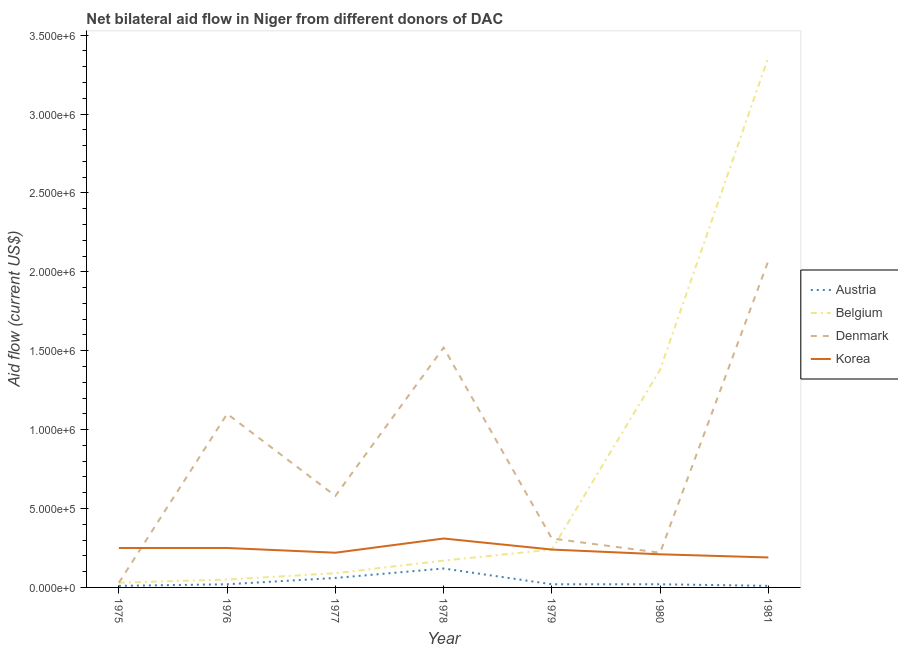How many different coloured lines are there?
Keep it short and to the point. 4. Does the line corresponding to amount of aid given by austria intersect with the line corresponding to amount of aid given by korea?
Keep it short and to the point. No. What is the amount of aid given by denmark in 1977?
Your answer should be very brief. 5.80e+05. Across all years, what is the maximum amount of aid given by korea?
Provide a succinct answer. 3.10e+05. Across all years, what is the minimum amount of aid given by belgium?
Make the answer very short. 3.00e+04. In which year was the amount of aid given by denmark minimum?
Your response must be concise. 1975. What is the total amount of aid given by belgium in the graph?
Provide a short and direct response. 5.32e+06. What is the difference between the amount of aid given by korea in 1975 and that in 1980?
Keep it short and to the point. 4.00e+04. What is the difference between the amount of aid given by denmark in 1981 and the amount of aid given by belgium in 1975?
Provide a succinct answer. 2.04e+06. What is the average amount of aid given by belgium per year?
Your answer should be compact. 7.60e+05. In the year 1981, what is the difference between the amount of aid given by korea and amount of aid given by denmark?
Provide a succinct answer. -1.88e+06. What is the ratio of the amount of aid given by belgium in 1979 to that in 1980?
Ensure brevity in your answer.  0.17. Is the amount of aid given by belgium in 1976 less than that in 1981?
Keep it short and to the point. Yes. Is the difference between the amount of aid given by denmark in 1976 and 1980 greater than the difference between the amount of aid given by korea in 1976 and 1980?
Your response must be concise. Yes. What is the difference between the highest and the lowest amount of aid given by denmark?
Provide a short and direct response. 2.04e+06. In how many years, is the amount of aid given by denmark greater than the average amount of aid given by denmark taken over all years?
Offer a very short reply. 3. Is the sum of the amount of aid given by denmark in 1978 and 1979 greater than the maximum amount of aid given by korea across all years?
Your answer should be compact. Yes. Is it the case that in every year, the sum of the amount of aid given by belgium and amount of aid given by austria is greater than the sum of amount of aid given by denmark and amount of aid given by korea?
Offer a terse response. No. Is it the case that in every year, the sum of the amount of aid given by austria and amount of aid given by belgium is greater than the amount of aid given by denmark?
Provide a short and direct response. No. Is the amount of aid given by austria strictly greater than the amount of aid given by korea over the years?
Your answer should be compact. No. Is the amount of aid given by austria strictly less than the amount of aid given by korea over the years?
Provide a succinct answer. Yes. Are the values on the major ticks of Y-axis written in scientific E-notation?
Offer a very short reply. Yes. Does the graph contain any zero values?
Your response must be concise. No. What is the title of the graph?
Your answer should be compact. Net bilateral aid flow in Niger from different donors of DAC. Does "WHO" appear as one of the legend labels in the graph?
Give a very brief answer. No. What is the Aid flow (current US$) of Austria in 1975?
Your response must be concise. 10000. What is the Aid flow (current US$) in Belgium in 1976?
Offer a terse response. 5.00e+04. What is the Aid flow (current US$) in Denmark in 1976?
Your response must be concise. 1.10e+06. What is the Aid flow (current US$) of Austria in 1977?
Keep it short and to the point. 6.00e+04. What is the Aid flow (current US$) of Denmark in 1977?
Offer a terse response. 5.80e+05. What is the Aid flow (current US$) in Korea in 1977?
Make the answer very short. 2.20e+05. What is the Aid flow (current US$) of Austria in 1978?
Your answer should be very brief. 1.20e+05. What is the Aid flow (current US$) of Denmark in 1978?
Provide a succinct answer. 1.52e+06. What is the Aid flow (current US$) of Korea in 1979?
Make the answer very short. 2.40e+05. What is the Aid flow (current US$) in Austria in 1980?
Make the answer very short. 2.00e+04. What is the Aid flow (current US$) in Belgium in 1980?
Your response must be concise. 1.38e+06. What is the Aid flow (current US$) of Denmark in 1980?
Give a very brief answer. 2.20e+05. What is the Aid flow (current US$) in Korea in 1980?
Offer a terse response. 2.10e+05. What is the Aid flow (current US$) of Austria in 1981?
Provide a succinct answer. 10000. What is the Aid flow (current US$) in Belgium in 1981?
Give a very brief answer. 3.36e+06. What is the Aid flow (current US$) of Denmark in 1981?
Provide a short and direct response. 2.07e+06. Across all years, what is the maximum Aid flow (current US$) of Belgium?
Provide a succinct answer. 3.36e+06. Across all years, what is the maximum Aid flow (current US$) in Denmark?
Your answer should be very brief. 2.07e+06. Across all years, what is the maximum Aid flow (current US$) in Korea?
Provide a succinct answer. 3.10e+05. Across all years, what is the minimum Aid flow (current US$) in Austria?
Your response must be concise. 10000. What is the total Aid flow (current US$) in Belgium in the graph?
Your answer should be compact. 5.32e+06. What is the total Aid flow (current US$) in Denmark in the graph?
Your answer should be very brief. 5.83e+06. What is the total Aid flow (current US$) in Korea in the graph?
Provide a succinct answer. 1.67e+06. What is the difference between the Aid flow (current US$) of Denmark in 1975 and that in 1976?
Provide a succinct answer. -1.07e+06. What is the difference between the Aid flow (current US$) in Austria in 1975 and that in 1977?
Ensure brevity in your answer.  -5.00e+04. What is the difference between the Aid flow (current US$) of Denmark in 1975 and that in 1977?
Make the answer very short. -5.50e+05. What is the difference between the Aid flow (current US$) in Korea in 1975 and that in 1977?
Keep it short and to the point. 3.00e+04. What is the difference between the Aid flow (current US$) of Denmark in 1975 and that in 1978?
Make the answer very short. -1.49e+06. What is the difference between the Aid flow (current US$) of Belgium in 1975 and that in 1979?
Offer a terse response. -2.10e+05. What is the difference between the Aid flow (current US$) of Denmark in 1975 and that in 1979?
Keep it short and to the point. -2.80e+05. What is the difference between the Aid flow (current US$) in Korea in 1975 and that in 1979?
Provide a succinct answer. 10000. What is the difference between the Aid flow (current US$) of Belgium in 1975 and that in 1980?
Your response must be concise. -1.35e+06. What is the difference between the Aid flow (current US$) of Korea in 1975 and that in 1980?
Your response must be concise. 4.00e+04. What is the difference between the Aid flow (current US$) in Austria in 1975 and that in 1981?
Ensure brevity in your answer.  0. What is the difference between the Aid flow (current US$) in Belgium in 1975 and that in 1981?
Give a very brief answer. -3.33e+06. What is the difference between the Aid flow (current US$) in Denmark in 1975 and that in 1981?
Give a very brief answer. -2.04e+06. What is the difference between the Aid flow (current US$) of Korea in 1975 and that in 1981?
Keep it short and to the point. 6.00e+04. What is the difference between the Aid flow (current US$) in Belgium in 1976 and that in 1977?
Ensure brevity in your answer.  -4.00e+04. What is the difference between the Aid flow (current US$) of Denmark in 1976 and that in 1977?
Your answer should be compact. 5.20e+05. What is the difference between the Aid flow (current US$) of Austria in 1976 and that in 1978?
Keep it short and to the point. -1.00e+05. What is the difference between the Aid flow (current US$) of Denmark in 1976 and that in 1978?
Keep it short and to the point. -4.20e+05. What is the difference between the Aid flow (current US$) of Korea in 1976 and that in 1978?
Keep it short and to the point. -6.00e+04. What is the difference between the Aid flow (current US$) of Belgium in 1976 and that in 1979?
Provide a short and direct response. -1.90e+05. What is the difference between the Aid flow (current US$) of Denmark in 1976 and that in 1979?
Ensure brevity in your answer.  7.90e+05. What is the difference between the Aid flow (current US$) in Austria in 1976 and that in 1980?
Make the answer very short. 0. What is the difference between the Aid flow (current US$) in Belgium in 1976 and that in 1980?
Ensure brevity in your answer.  -1.33e+06. What is the difference between the Aid flow (current US$) of Denmark in 1976 and that in 1980?
Keep it short and to the point. 8.80e+05. What is the difference between the Aid flow (current US$) in Austria in 1976 and that in 1981?
Provide a short and direct response. 10000. What is the difference between the Aid flow (current US$) of Belgium in 1976 and that in 1981?
Provide a succinct answer. -3.31e+06. What is the difference between the Aid flow (current US$) of Denmark in 1976 and that in 1981?
Offer a terse response. -9.70e+05. What is the difference between the Aid flow (current US$) in Austria in 1977 and that in 1978?
Offer a terse response. -6.00e+04. What is the difference between the Aid flow (current US$) in Denmark in 1977 and that in 1978?
Your answer should be very brief. -9.40e+05. What is the difference between the Aid flow (current US$) of Korea in 1977 and that in 1978?
Your answer should be compact. -9.00e+04. What is the difference between the Aid flow (current US$) in Austria in 1977 and that in 1979?
Your answer should be compact. 4.00e+04. What is the difference between the Aid flow (current US$) in Korea in 1977 and that in 1979?
Keep it short and to the point. -2.00e+04. What is the difference between the Aid flow (current US$) of Belgium in 1977 and that in 1980?
Offer a very short reply. -1.29e+06. What is the difference between the Aid flow (current US$) of Denmark in 1977 and that in 1980?
Offer a very short reply. 3.60e+05. What is the difference between the Aid flow (current US$) in Korea in 1977 and that in 1980?
Provide a short and direct response. 10000. What is the difference between the Aid flow (current US$) in Austria in 1977 and that in 1981?
Keep it short and to the point. 5.00e+04. What is the difference between the Aid flow (current US$) of Belgium in 1977 and that in 1981?
Your response must be concise. -3.27e+06. What is the difference between the Aid flow (current US$) in Denmark in 1977 and that in 1981?
Provide a succinct answer. -1.49e+06. What is the difference between the Aid flow (current US$) in Korea in 1977 and that in 1981?
Offer a terse response. 3.00e+04. What is the difference between the Aid flow (current US$) of Austria in 1978 and that in 1979?
Offer a very short reply. 1.00e+05. What is the difference between the Aid flow (current US$) of Denmark in 1978 and that in 1979?
Offer a very short reply. 1.21e+06. What is the difference between the Aid flow (current US$) in Korea in 1978 and that in 1979?
Your response must be concise. 7.00e+04. What is the difference between the Aid flow (current US$) in Austria in 1978 and that in 1980?
Provide a succinct answer. 1.00e+05. What is the difference between the Aid flow (current US$) of Belgium in 1978 and that in 1980?
Provide a succinct answer. -1.21e+06. What is the difference between the Aid flow (current US$) in Denmark in 1978 and that in 1980?
Provide a short and direct response. 1.30e+06. What is the difference between the Aid flow (current US$) of Austria in 1978 and that in 1981?
Provide a succinct answer. 1.10e+05. What is the difference between the Aid flow (current US$) of Belgium in 1978 and that in 1981?
Ensure brevity in your answer.  -3.19e+06. What is the difference between the Aid flow (current US$) in Denmark in 1978 and that in 1981?
Ensure brevity in your answer.  -5.50e+05. What is the difference between the Aid flow (current US$) in Korea in 1978 and that in 1981?
Provide a short and direct response. 1.20e+05. What is the difference between the Aid flow (current US$) of Belgium in 1979 and that in 1980?
Give a very brief answer. -1.14e+06. What is the difference between the Aid flow (current US$) in Korea in 1979 and that in 1980?
Ensure brevity in your answer.  3.00e+04. What is the difference between the Aid flow (current US$) of Belgium in 1979 and that in 1981?
Make the answer very short. -3.12e+06. What is the difference between the Aid flow (current US$) in Denmark in 1979 and that in 1981?
Ensure brevity in your answer.  -1.76e+06. What is the difference between the Aid flow (current US$) in Austria in 1980 and that in 1981?
Provide a short and direct response. 10000. What is the difference between the Aid flow (current US$) of Belgium in 1980 and that in 1981?
Your answer should be very brief. -1.98e+06. What is the difference between the Aid flow (current US$) in Denmark in 1980 and that in 1981?
Offer a terse response. -1.85e+06. What is the difference between the Aid flow (current US$) in Korea in 1980 and that in 1981?
Your response must be concise. 2.00e+04. What is the difference between the Aid flow (current US$) of Austria in 1975 and the Aid flow (current US$) of Belgium in 1976?
Provide a short and direct response. -4.00e+04. What is the difference between the Aid flow (current US$) in Austria in 1975 and the Aid flow (current US$) in Denmark in 1976?
Your answer should be very brief. -1.09e+06. What is the difference between the Aid flow (current US$) of Belgium in 1975 and the Aid flow (current US$) of Denmark in 1976?
Provide a succinct answer. -1.07e+06. What is the difference between the Aid flow (current US$) of Austria in 1975 and the Aid flow (current US$) of Belgium in 1977?
Ensure brevity in your answer.  -8.00e+04. What is the difference between the Aid flow (current US$) of Austria in 1975 and the Aid flow (current US$) of Denmark in 1977?
Keep it short and to the point. -5.70e+05. What is the difference between the Aid flow (current US$) of Belgium in 1975 and the Aid flow (current US$) of Denmark in 1977?
Your response must be concise. -5.50e+05. What is the difference between the Aid flow (current US$) of Denmark in 1975 and the Aid flow (current US$) of Korea in 1977?
Provide a short and direct response. -1.90e+05. What is the difference between the Aid flow (current US$) in Austria in 1975 and the Aid flow (current US$) in Denmark in 1978?
Provide a succinct answer. -1.51e+06. What is the difference between the Aid flow (current US$) in Belgium in 1975 and the Aid flow (current US$) in Denmark in 1978?
Ensure brevity in your answer.  -1.49e+06. What is the difference between the Aid flow (current US$) in Belgium in 1975 and the Aid flow (current US$) in Korea in 1978?
Offer a terse response. -2.80e+05. What is the difference between the Aid flow (current US$) in Denmark in 1975 and the Aid flow (current US$) in Korea in 1978?
Offer a terse response. -2.80e+05. What is the difference between the Aid flow (current US$) in Austria in 1975 and the Aid flow (current US$) in Denmark in 1979?
Provide a short and direct response. -3.00e+05. What is the difference between the Aid flow (current US$) of Belgium in 1975 and the Aid flow (current US$) of Denmark in 1979?
Your answer should be compact. -2.80e+05. What is the difference between the Aid flow (current US$) of Austria in 1975 and the Aid flow (current US$) of Belgium in 1980?
Your answer should be compact. -1.37e+06. What is the difference between the Aid flow (current US$) in Austria in 1975 and the Aid flow (current US$) in Denmark in 1980?
Offer a very short reply. -2.10e+05. What is the difference between the Aid flow (current US$) of Denmark in 1975 and the Aid flow (current US$) of Korea in 1980?
Your answer should be very brief. -1.80e+05. What is the difference between the Aid flow (current US$) of Austria in 1975 and the Aid flow (current US$) of Belgium in 1981?
Ensure brevity in your answer.  -3.35e+06. What is the difference between the Aid flow (current US$) of Austria in 1975 and the Aid flow (current US$) of Denmark in 1981?
Your answer should be compact. -2.06e+06. What is the difference between the Aid flow (current US$) of Austria in 1975 and the Aid flow (current US$) of Korea in 1981?
Keep it short and to the point. -1.80e+05. What is the difference between the Aid flow (current US$) in Belgium in 1975 and the Aid flow (current US$) in Denmark in 1981?
Ensure brevity in your answer.  -2.04e+06. What is the difference between the Aid flow (current US$) of Belgium in 1975 and the Aid flow (current US$) of Korea in 1981?
Make the answer very short. -1.60e+05. What is the difference between the Aid flow (current US$) of Austria in 1976 and the Aid flow (current US$) of Belgium in 1977?
Offer a terse response. -7.00e+04. What is the difference between the Aid flow (current US$) in Austria in 1976 and the Aid flow (current US$) in Denmark in 1977?
Your answer should be compact. -5.60e+05. What is the difference between the Aid flow (current US$) of Austria in 1976 and the Aid flow (current US$) of Korea in 1977?
Your response must be concise. -2.00e+05. What is the difference between the Aid flow (current US$) in Belgium in 1976 and the Aid flow (current US$) in Denmark in 1977?
Ensure brevity in your answer.  -5.30e+05. What is the difference between the Aid flow (current US$) of Belgium in 1976 and the Aid flow (current US$) of Korea in 1977?
Keep it short and to the point. -1.70e+05. What is the difference between the Aid flow (current US$) in Denmark in 1976 and the Aid flow (current US$) in Korea in 1977?
Ensure brevity in your answer.  8.80e+05. What is the difference between the Aid flow (current US$) of Austria in 1976 and the Aid flow (current US$) of Belgium in 1978?
Your answer should be very brief. -1.50e+05. What is the difference between the Aid flow (current US$) of Austria in 1976 and the Aid flow (current US$) of Denmark in 1978?
Ensure brevity in your answer.  -1.50e+06. What is the difference between the Aid flow (current US$) of Austria in 1976 and the Aid flow (current US$) of Korea in 1978?
Your answer should be compact. -2.90e+05. What is the difference between the Aid flow (current US$) of Belgium in 1976 and the Aid flow (current US$) of Denmark in 1978?
Provide a short and direct response. -1.47e+06. What is the difference between the Aid flow (current US$) of Denmark in 1976 and the Aid flow (current US$) of Korea in 1978?
Offer a very short reply. 7.90e+05. What is the difference between the Aid flow (current US$) of Austria in 1976 and the Aid flow (current US$) of Belgium in 1979?
Your answer should be very brief. -2.20e+05. What is the difference between the Aid flow (current US$) of Austria in 1976 and the Aid flow (current US$) of Korea in 1979?
Your answer should be very brief. -2.20e+05. What is the difference between the Aid flow (current US$) in Belgium in 1976 and the Aid flow (current US$) in Denmark in 1979?
Offer a terse response. -2.60e+05. What is the difference between the Aid flow (current US$) in Denmark in 1976 and the Aid flow (current US$) in Korea in 1979?
Keep it short and to the point. 8.60e+05. What is the difference between the Aid flow (current US$) of Austria in 1976 and the Aid flow (current US$) of Belgium in 1980?
Make the answer very short. -1.36e+06. What is the difference between the Aid flow (current US$) in Belgium in 1976 and the Aid flow (current US$) in Denmark in 1980?
Keep it short and to the point. -1.70e+05. What is the difference between the Aid flow (current US$) of Belgium in 1976 and the Aid flow (current US$) of Korea in 1980?
Ensure brevity in your answer.  -1.60e+05. What is the difference between the Aid flow (current US$) of Denmark in 1976 and the Aid flow (current US$) of Korea in 1980?
Provide a short and direct response. 8.90e+05. What is the difference between the Aid flow (current US$) of Austria in 1976 and the Aid flow (current US$) of Belgium in 1981?
Your answer should be very brief. -3.34e+06. What is the difference between the Aid flow (current US$) in Austria in 1976 and the Aid flow (current US$) in Denmark in 1981?
Offer a very short reply. -2.05e+06. What is the difference between the Aid flow (current US$) in Austria in 1976 and the Aid flow (current US$) in Korea in 1981?
Your response must be concise. -1.70e+05. What is the difference between the Aid flow (current US$) in Belgium in 1976 and the Aid flow (current US$) in Denmark in 1981?
Your answer should be very brief. -2.02e+06. What is the difference between the Aid flow (current US$) of Denmark in 1976 and the Aid flow (current US$) of Korea in 1981?
Offer a terse response. 9.10e+05. What is the difference between the Aid flow (current US$) of Austria in 1977 and the Aid flow (current US$) of Belgium in 1978?
Provide a short and direct response. -1.10e+05. What is the difference between the Aid flow (current US$) of Austria in 1977 and the Aid flow (current US$) of Denmark in 1978?
Your answer should be very brief. -1.46e+06. What is the difference between the Aid flow (current US$) in Austria in 1977 and the Aid flow (current US$) in Korea in 1978?
Keep it short and to the point. -2.50e+05. What is the difference between the Aid flow (current US$) of Belgium in 1977 and the Aid flow (current US$) of Denmark in 1978?
Offer a terse response. -1.43e+06. What is the difference between the Aid flow (current US$) of Belgium in 1977 and the Aid flow (current US$) of Korea in 1978?
Your answer should be very brief. -2.20e+05. What is the difference between the Aid flow (current US$) in Denmark in 1977 and the Aid flow (current US$) in Korea in 1978?
Your answer should be compact. 2.70e+05. What is the difference between the Aid flow (current US$) of Belgium in 1977 and the Aid flow (current US$) of Denmark in 1979?
Keep it short and to the point. -2.20e+05. What is the difference between the Aid flow (current US$) in Austria in 1977 and the Aid flow (current US$) in Belgium in 1980?
Provide a succinct answer. -1.32e+06. What is the difference between the Aid flow (current US$) in Belgium in 1977 and the Aid flow (current US$) in Denmark in 1980?
Keep it short and to the point. -1.30e+05. What is the difference between the Aid flow (current US$) in Austria in 1977 and the Aid flow (current US$) in Belgium in 1981?
Give a very brief answer. -3.30e+06. What is the difference between the Aid flow (current US$) in Austria in 1977 and the Aid flow (current US$) in Denmark in 1981?
Your answer should be compact. -2.01e+06. What is the difference between the Aid flow (current US$) of Belgium in 1977 and the Aid flow (current US$) of Denmark in 1981?
Ensure brevity in your answer.  -1.98e+06. What is the difference between the Aid flow (current US$) in Austria in 1978 and the Aid flow (current US$) in Belgium in 1979?
Your response must be concise. -1.20e+05. What is the difference between the Aid flow (current US$) of Austria in 1978 and the Aid flow (current US$) of Denmark in 1979?
Offer a very short reply. -1.90e+05. What is the difference between the Aid flow (current US$) in Belgium in 1978 and the Aid flow (current US$) in Denmark in 1979?
Make the answer very short. -1.40e+05. What is the difference between the Aid flow (current US$) in Denmark in 1978 and the Aid flow (current US$) in Korea in 1979?
Your response must be concise. 1.28e+06. What is the difference between the Aid flow (current US$) in Austria in 1978 and the Aid flow (current US$) in Belgium in 1980?
Offer a very short reply. -1.26e+06. What is the difference between the Aid flow (current US$) in Austria in 1978 and the Aid flow (current US$) in Denmark in 1980?
Your response must be concise. -1.00e+05. What is the difference between the Aid flow (current US$) of Austria in 1978 and the Aid flow (current US$) of Korea in 1980?
Offer a very short reply. -9.00e+04. What is the difference between the Aid flow (current US$) of Belgium in 1978 and the Aid flow (current US$) of Korea in 1980?
Provide a succinct answer. -4.00e+04. What is the difference between the Aid flow (current US$) in Denmark in 1978 and the Aid flow (current US$) in Korea in 1980?
Give a very brief answer. 1.31e+06. What is the difference between the Aid flow (current US$) in Austria in 1978 and the Aid flow (current US$) in Belgium in 1981?
Provide a succinct answer. -3.24e+06. What is the difference between the Aid flow (current US$) in Austria in 1978 and the Aid flow (current US$) in Denmark in 1981?
Offer a very short reply. -1.95e+06. What is the difference between the Aid flow (current US$) of Belgium in 1978 and the Aid flow (current US$) of Denmark in 1981?
Your answer should be very brief. -1.90e+06. What is the difference between the Aid flow (current US$) in Denmark in 1978 and the Aid flow (current US$) in Korea in 1981?
Offer a very short reply. 1.33e+06. What is the difference between the Aid flow (current US$) of Austria in 1979 and the Aid flow (current US$) of Belgium in 1980?
Ensure brevity in your answer.  -1.36e+06. What is the difference between the Aid flow (current US$) of Austria in 1979 and the Aid flow (current US$) of Denmark in 1980?
Your answer should be very brief. -2.00e+05. What is the difference between the Aid flow (current US$) of Austria in 1979 and the Aid flow (current US$) of Belgium in 1981?
Ensure brevity in your answer.  -3.34e+06. What is the difference between the Aid flow (current US$) in Austria in 1979 and the Aid flow (current US$) in Denmark in 1981?
Ensure brevity in your answer.  -2.05e+06. What is the difference between the Aid flow (current US$) of Austria in 1979 and the Aid flow (current US$) of Korea in 1981?
Offer a very short reply. -1.70e+05. What is the difference between the Aid flow (current US$) of Belgium in 1979 and the Aid flow (current US$) of Denmark in 1981?
Give a very brief answer. -1.83e+06. What is the difference between the Aid flow (current US$) in Belgium in 1979 and the Aid flow (current US$) in Korea in 1981?
Make the answer very short. 5.00e+04. What is the difference between the Aid flow (current US$) of Austria in 1980 and the Aid flow (current US$) of Belgium in 1981?
Ensure brevity in your answer.  -3.34e+06. What is the difference between the Aid flow (current US$) in Austria in 1980 and the Aid flow (current US$) in Denmark in 1981?
Your response must be concise. -2.05e+06. What is the difference between the Aid flow (current US$) in Belgium in 1980 and the Aid flow (current US$) in Denmark in 1981?
Your answer should be very brief. -6.90e+05. What is the difference between the Aid flow (current US$) in Belgium in 1980 and the Aid flow (current US$) in Korea in 1981?
Ensure brevity in your answer.  1.19e+06. What is the difference between the Aid flow (current US$) in Denmark in 1980 and the Aid flow (current US$) in Korea in 1981?
Make the answer very short. 3.00e+04. What is the average Aid flow (current US$) in Austria per year?
Keep it short and to the point. 3.71e+04. What is the average Aid flow (current US$) of Belgium per year?
Give a very brief answer. 7.60e+05. What is the average Aid flow (current US$) in Denmark per year?
Offer a very short reply. 8.33e+05. What is the average Aid flow (current US$) in Korea per year?
Ensure brevity in your answer.  2.39e+05. In the year 1975, what is the difference between the Aid flow (current US$) of Belgium and Aid flow (current US$) of Denmark?
Your answer should be compact. 0. In the year 1975, what is the difference between the Aid flow (current US$) of Denmark and Aid flow (current US$) of Korea?
Ensure brevity in your answer.  -2.20e+05. In the year 1976, what is the difference between the Aid flow (current US$) of Austria and Aid flow (current US$) of Denmark?
Give a very brief answer. -1.08e+06. In the year 1976, what is the difference between the Aid flow (current US$) in Belgium and Aid flow (current US$) in Denmark?
Provide a succinct answer. -1.05e+06. In the year 1976, what is the difference between the Aid flow (current US$) in Denmark and Aid flow (current US$) in Korea?
Your answer should be very brief. 8.50e+05. In the year 1977, what is the difference between the Aid flow (current US$) in Austria and Aid flow (current US$) in Denmark?
Offer a very short reply. -5.20e+05. In the year 1977, what is the difference between the Aid flow (current US$) of Belgium and Aid flow (current US$) of Denmark?
Provide a succinct answer. -4.90e+05. In the year 1978, what is the difference between the Aid flow (current US$) in Austria and Aid flow (current US$) in Denmark?
Your answer should be very brief. -1.40e+06. In the year 1978, what is the difference between the Aid flow (current US$) in Belgium and Aid flow (current US$) in Denmark?
Offer a terse response. -1.35e+06. In the year 1978, what is the difference between the Aid flow (current US$) in Belgium and Aid flow (current US$) in Korea?
Provide a succinct answer. -1.40e+05. In the year 1978, what is the difference between the Aid flow (current US$) in Denmark and Aid flow (current US$) in Korea?
Your answer should be compact. 1.21e+06. In the year 1979, what is the difference between the Aid flow (current US$) in Austria and Aid flow (current US$) in Belgium?
Offer a very short reply. -2.20e+05. In the year 1980, what is the difference between the Aid flow (current US$) in Austria and Aid flow (current US$) in Belgium?
Offer a terse response. -1.36e+06. In the year 1980, what is the difference between the Aid flow (current US$) of Austria and Aid flow (current US$) of Korea?
Offer a terse response. -1.90e+05. In the year 1980, what is the difference between the Aid flow (current US$) of Belgium and Aid flow (current US$) of Denmark?
Make the answer very short. 1.16e+06. In the year 1980, what is the difference between the Aid flow (current US$) in Belgium and Aid flow (current US$) in Korea?
Offer a very short reply. 1.17e+06. In the year 1980, what is the difference between the Aid flow (current US$) of Denmark and Aid flow (current US$) of Korea?
Your response must be concise. 10000. In the year 1981, what is the difference between the Aid flow (current US$) in Austria and Aid flow (current US$) in Belgium?
Offer a very short reply. -3.35e+06. In the year 1981, what is the difference between the Aid flow (current US$) in Austria and Aid flow (current US$) in Denmark?
Give a very brief answer. -2.06e+06. In the year 1981, what is the difference between the Aid flow (current US$) of Belgium and Aid flow (current US$) of Denmark?
Keep it short and to the point. 1.29e+06. In the year 1981, what is the difference between the Aid flow (current US$) of Belgium and Aid flow (current US$) of Korea?
Give a very brief answer. 3.17e+06. In the year 1981, what is the difference between the Aid flow (current US$) in Denmark and Aid flow (current US$) in Korea?
Keep it short and to the point. 1.88e+06. What is the ratio of the Aid flow (current US$) in Austria in 1975 to that in 1976?
Keep it short and to the point. 0.5. What is the ratio of the Aid flow (current US$) of Denmark in 1975 to that in 1976?
Make the answer very short. 0.03. What is the ratio of the Aid flow (current US$) of Korea in 1975 to that in 1976?
Make the answer very short. 1. What is the ratio of the Aid flow (current US$) in Denmark in 1975 to that in 1977?
Give a very brief answer. 0.05. What is the ratio of the Aid flow (current US$) in Korea in 1975 to that in 1977?
Offer a very short reply. 1.14. What is the ratio of the Aid flow (current US$) of Austria in 1975 to that in 1978?
Make the answer very short. 0.08. What is the ratio of the Aid flow (current US$) in Belgium in 1975 to that in 1978?
Your answer should be compact. 0.18. What is the ratio of the Aid flow (current US$) of Denmark in 1975 to that in 1978?
Provide a short and direct response. 0.02. What is the ratio of the Aid flow (current US$) in Korea in 1975 to that in 1978?
Ensure brevity in your answer.  0.81. What is the ratio of the Aid flow (current US$) of Belgium in 1975 to that in 1979?
Your answer should be very brief. 0.12. What is the ratio of the Aid flow (current US$) of Denmark in 1975 to that in 1979?
Make the answer very short. 0.1. What is the ratio of the Aid flow (current US$) of Korea in 1975 to that in 1979?
Make the answer very short. 1.04. What is the ratio of the Aid flow (current US$) of Belgium in 1975 to that in 1980?
Ensure brevity in your answer.  0.02. What is the ratio of the Aid flow (current US$) of Denmark in 1975 to that in 1980?
Provide a short and direct response. 0.14. What is the ratio of the Aid flow (current US$) of Korea in 1975 to that in 1980?
Keep it short and to the point. 1.19. What is the ratio of the Aid flow (current US$) in Belgium in 1975 to that in 1981?
Your answer should be very brief. 0.01. What is the ratio of the Aid flow (current US$) of Denmark in 1975 to that in 1981?
Offer a very short reply. 0.01. What is the ratio of the Aid flow (current US$) in Korea in 1975 to that in 1981?
Your response must be concise. 1.32. What is the ratio of the Aid flow (current US$) in Austria in 1976 to that in 1977?
Your answer should be compact. 0.33. What is the ratio of the Aid flow (current US$) in Belgium in 1976 to that in 1977?
Your answer should be compact. 0.56. What is the ratio of the Aid flow (current US$) of Denmark in 1976 to that in 1977?
Keep it short and to the point. 1.9. What is the ratio of the Aid flow (current US$) of Korea in 1976 to that in 1977?
Make the answer very short. 1.14. What is the ratio of the Aid flow (current US$) in Belgium in 1976 to that in 1978?
Your response must be concise. 0.29. What is the ratio of the Aid flow (current US$) in Denmark in 1976 to that in 1978?
Give a very brief answer. 0.72. What is the ratio of the Aid flow (current US$) in Korea in 1976 to that in 1978?
Your answer should be very brief. 0.81. What is the ratio of the Aid flow (current US$) in Austria in 1976 to that in 1979?
Offer a very short reply. 1. What is the ratio of the Aid flow (current US$) in Belgium in 1976 to that in 1979?
Your answer should be compact. 0.21. What is the ratio of the Aid flow (current US$) of Denmark in 1976 to that in 1979?
Make the answer very short. 3.55. What is the ratio of the Aid flow (current US$) in Korea in 1976 to that in 1979?
Give a very brief answer. 1.04. What is the ratio of the Aid flow (current US$) of Belgium in 1976 to that in 1980?
Give a very brief answer. 0.04. What is the ratio of the Aid flow (current US$) of Korea in 1976 to that in 1980?
Provide a succinct answer. 1.19. What is the ratio of the Aid flow (current US$) in Belgium in 1976 to that in 1981?
Ensure brevity in your answer.  0.01. What is the ratio of the Aid flow (current US$) of Denmark in 1976 to that in 1981?
Your answer should be very brief. 0.53. What is the ratio of the Aid flow (current US$) in Korea in 1976 to that in 1981?
Keep it short and to the point. 1.32. What is the ratio of the Aid flow (current US$) of Belgium in 1977 to that in 1978?
Your response must be concise. 0.53. What is the ratio of the Aid flow (current US$) of Denmark in 1977 to that in 1978?
Make the answer very short. 0.38. What is the ratio of the Aid flow (current US$) of Korea in 1977 to that in 1978?
Keep it short and to the point. 0.71. What is the ratio of the Aid flow (current US$) of Austria in 1977 to that in 1979?
Your response must be concise. 3. What is the ratio of the Aid flow (current US$) of Denmark in 1977 to that in 1979?
Your response must be concise. 1.87. What is the ratio of the Aid flow (current US$) of Korea in 1977 to that in 1979?
Your answer should be compact. 0.92. What is the ratio of the Aid flow (current US$) of Austria in 1977 to that in 1980?
Your response must be concise. 3. What is the ratio of the Aid flow (current US$) of Belgium in 1977 to that in 1980?
Ensure brevity in your answer.  0.07. What is the ratio of the Aid flow (current US$) of Denmark in 1977 to that in 1980?
Offer a terse response. 2.64. What is the ratio of the Aid flow (current US$) in Korea in 1977 to that in 1980?
Make the answer very short. 1.05. What is the ratio of the Aid flow (current US$) in Austria in 1977 to that in 1981?
Give a very brief answer. 6. What is the ratio of the Aid flow (current US$) in Belgium in 1977 to that in 1981?
Your answer should be compact. 0.03. What is the ratio of the Aid flow (current US$) of Denmark in 1977 to that in 1981?
Offer a terse response. 0.28. What is the ratio of the Aid flow (current US$) in Korea in 1977 to that in 1981?
Keep it short and to the point. 1.16. What is the ratio of the Aid flow (current US$) in Austria in 1978 to that in 1979?
Your response must be concise. 6. What is the ratio of the Aid flow (current US$) of Belgium in 1978 to that in 1979?
Your answer should be very brief. 0.71. What is the ratio of the Aid flow (current US$) of Denmark in 1978 to that in 1979?
Offer a terse response. 4.9. What is the ratio of the Aid flow (current US$) of Korea in 1978 to that in 1979?
Your answer should be compact. 1.29. What is the ratio of the Aid flow (current US$) in Belgium in 1978 to that in 1980?
Offer a terse response. 0.12. What is the ratio of the Aid flow (current US$) in Denmark in 1978 to that in 1980?
Offer a very short reply. 6.91. What is the ratio of the Aid flow (current US$) of Korea in 1978 to that in 1980?
Your answer should be compact. 1.48. What is the ratio of the Aid flow (current US$) in Austria in 1978 to that in 1981?
Make the answer very short. 12. What is the ratio of the Aid flow (current US$) in Belgium in 1978 to that in 1981?
Offer a very short reply. 0.05. What is the ratio of the Aid flow (current US$) in Denmark in 1978 to that in 1981?
Make the answer very short. 0.73. What is the ratio of the Aid flow (current US$) in Korea in 1978 to that in 1981?
Your answer should be compact. 1.63. What is the ratio of the Aid flow (current US$) in Austria in 1979 to that in 1980?
Provide a succinct answer. 1. What is the ratio of the Aid flow (current US$) of Belgium in 1979 to that in 1980?
Give a very brief answer. 0.17. What is the ratio of the Aid flow (current US$) in Denmark in 1979 to that in 1980?
Provide a succinct answer. 1.41. What is the ratio of the Aid flow (current US$) of Belgium in 1979 to that in 1981?
Provide a succinct answer. 0.07. What is the ratio of the Aid flow (current US$) in Denmark in 1979 to that in 1981?
Ensure brevity in your answer.  0.15. What is the ratio of the Aid flow (current US$) in Korea in 1979 to that in 1981?
Keep it short and to the point. 1.26. What is the ratio of the Aid flow (current US$) in Austria in 1980 to that in 1981?
Give a very brief answer. 2. What is the ratio of the Aid flow (current US$) of Belgium in 1980 to that in 1981?
Give a very brief answer. 0.41. What is the ratio of the Aid flow (current US$) of Denmark in 1980 to that in 1981?
Make the answer very short. 0.11. What is the ratio of the Aid flow (current US$) of Korea in 1980 to that in 1981?
Your answer should be compact. 1.11. What is the difference between the highest and the second highest Aid flow (current US$) of Belgium?
Give a very brief answer. 1.98e+06. What is the difference between the highest and the second highest Aid flow (current US$) of Denmark?
Give a very brief answer. 5.50e+05. What is the difference between the highest and the lowest Aid flow (current US$) of Austria?
Make the answer very short. 1.10e+05. What is the difference between the highest and the lowest Aid flow (current US$) in Belgium?
Your answer should be very brief. 3.33e+06. What is the difference between the highest and the lowest Aid flow (current US$) in Denmark?
Give a very brief answer. 2.04e+06. What is the difference between the highest and the lowest Aid flow (current US$) in Korea?
Give a very brief answer. 1.20e+05. 